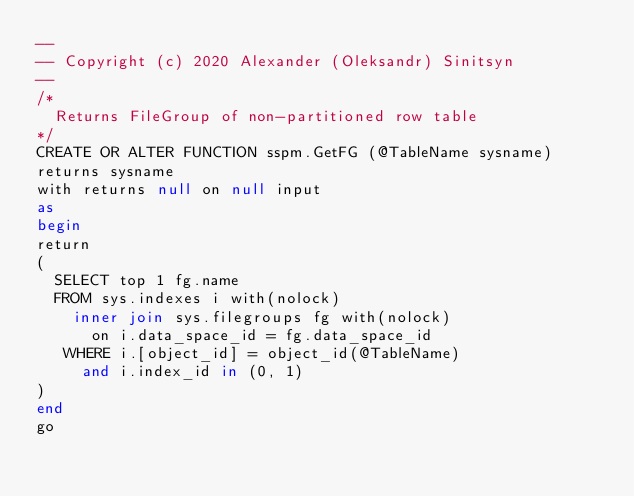<code> <loc_0><loc_0><loc_500><loc_500><_SQL_>--
-- Copyright (c) 2020 Alexander (Oleksandr) Sinitsyn
--
/*
  Returns FileGroup of non-partitioned row table
*/
CREATE OR ALTER FUNCTION sspm.GetFG (@TableName sysname)
returns sysname
with returns null on null input
as
begin
return
(
  SELECT top 1 fg.name
  FROM sys.indexes i with(nolock)
    inner join sys.filegroups fg with(nolock)
      on i.data_space_id = fg.data_space_id
   WHERE i.[object_id] = object_id(@TableName)
     and i.index_id in (0, 1)
)
end
go
</code> 